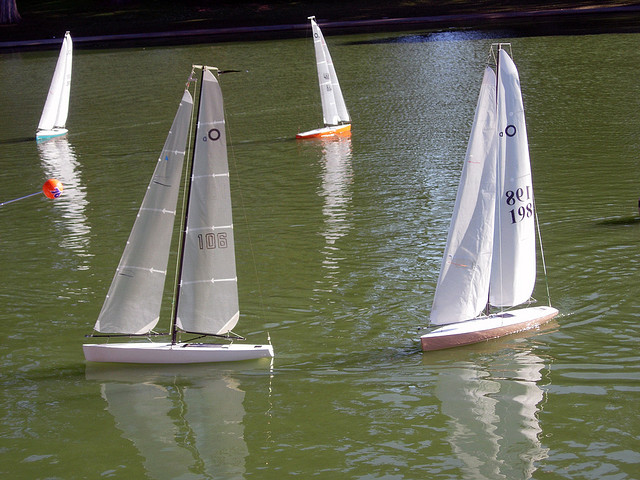Identify and read out the text in this image. O 106 O 198 198 